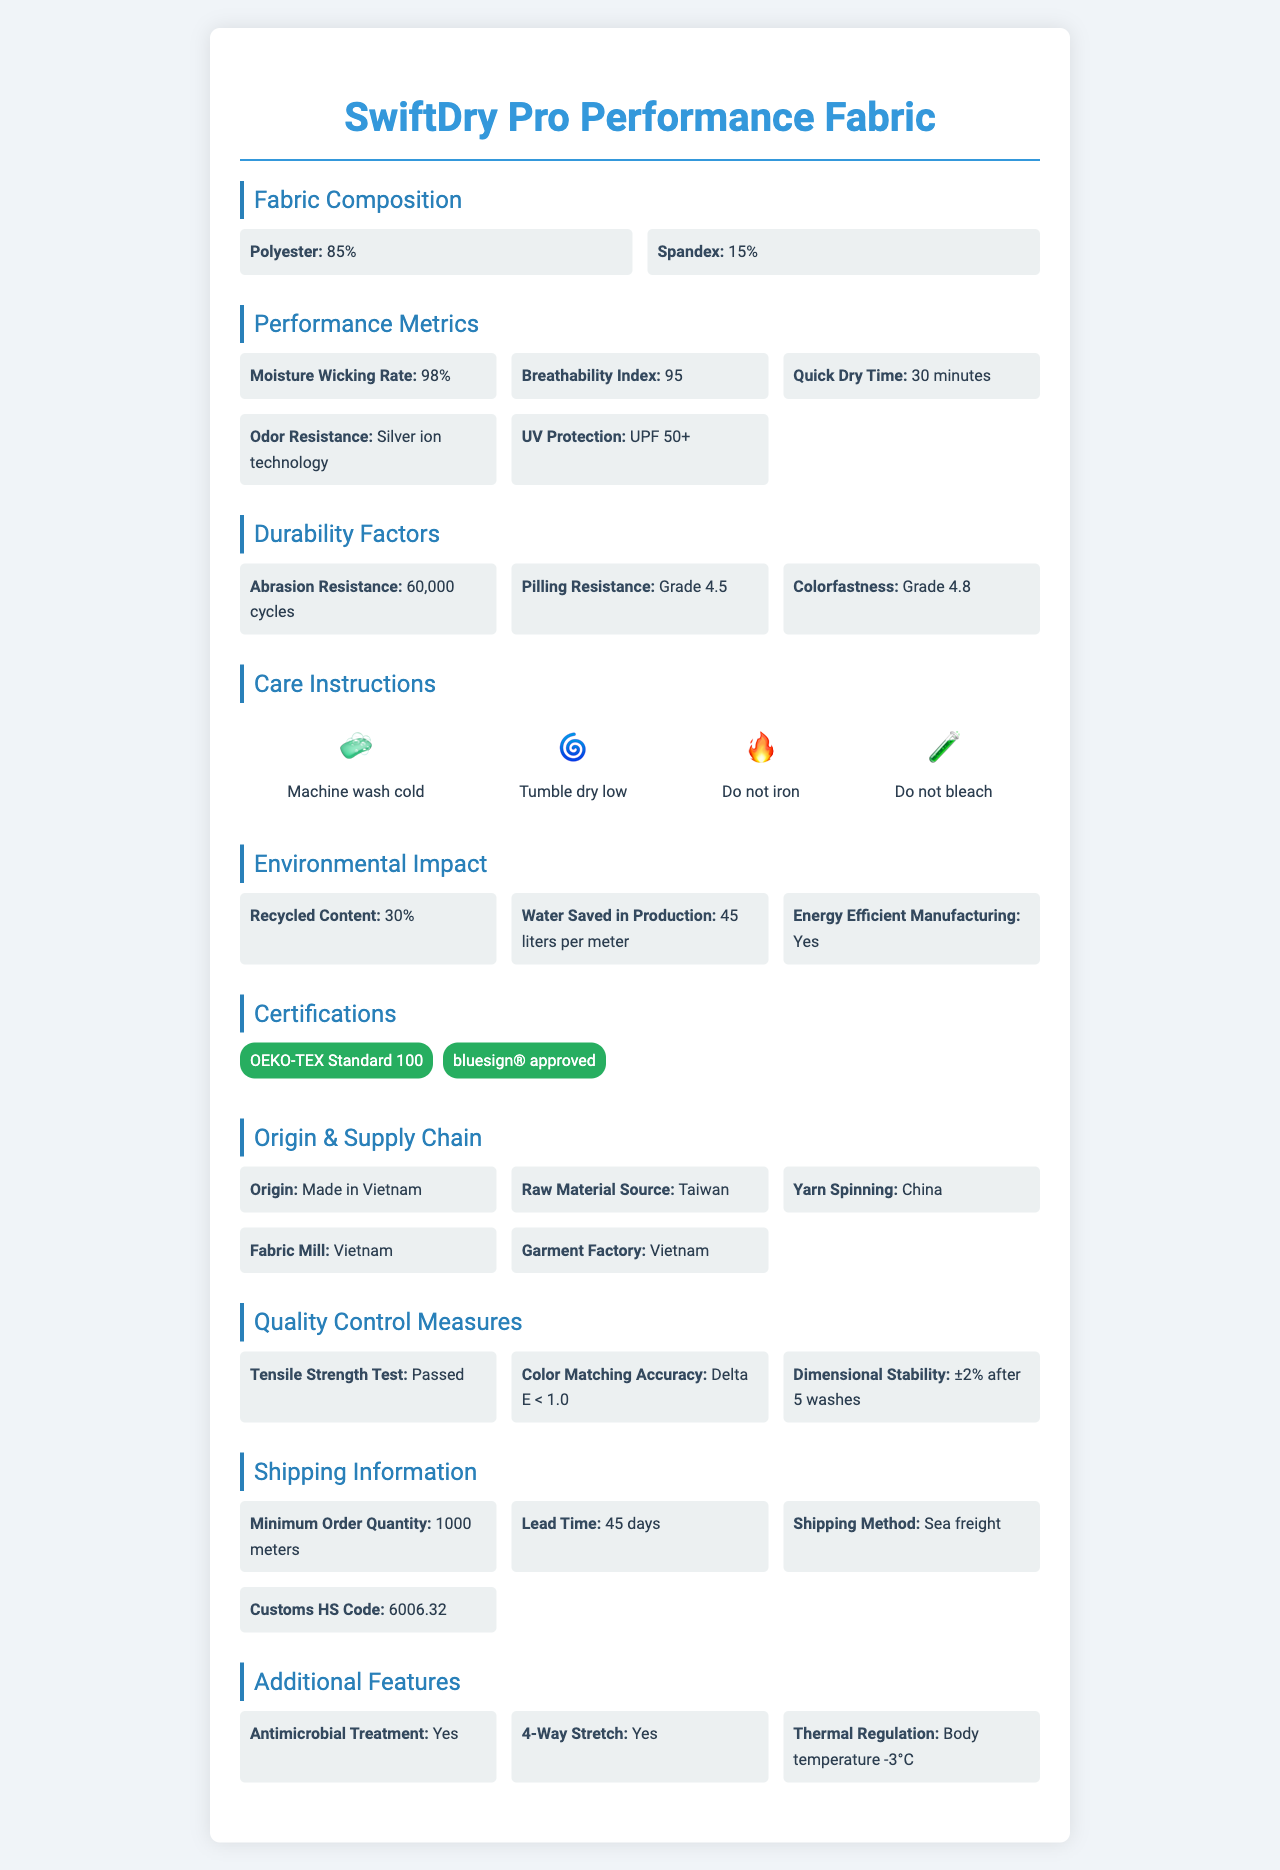what is the name of the fabric? The product name is mentioned at the top of the document, clearly stating "SwiftDry Pro Performance Fabric".
Answer: SwiftDry Pro Performance Fabric what percentage of the fabric composition is polyester? In the 'Fabric Composition' section, it states that the polyester content is 85%.
Answer: 85% how much water is saved in production per meter? In the 'Environmental Impact' section, it is noted that 45 liters per meter are saved in production.
Answer: 45 liters per meter what is the breathability index of this fabric? The 'Performance Metrics' section lists a breathability index of 95.
Answer: 95 what is the minimum order quantity for shipping? The 'Shipping Information' section specifies the minimum order quantity as 1000 meters.
Answer: 1000 meters In which country is the garment factory located? The 'Supply Chain Transparency' section mentions that the garment factory is in Vietnam.
Answer: Vietnam What is used for odor resistance in the fabric? The 'Performance Metrics' section states that silver ion technology is used for odor resistance.
Answer: Silver ion technology How should the fabric be washed? The 'Care Instructions' section advises to machine wash cold.
Answer: Machine wash cold which of the following is a performance metric of the fabric? A. Abrasion resistance B. Tensile strength test C. UV protection D. Washing UV protection is mentioned under 'Performance Metrics', while abrasion resistance and tensile strength test are listed under different sections.
Answer: C. UV protection What is the UV protection rating of the fabric? A. UPF 30 B. UPF 40 C. UPF 50 D. UPF 50+ The 'Performance Metrics' section specifically mentions "UPF 50+" for UV protection.
Answer: D. UPF 50+ Is the fabric antimicrobial treated? Under 'Additional Features', it mentions that the fabric has antimicrobial treatment.
Answer: Yes Does the fabric contain more than 20% spandex? The 'Fabric Composition' section states that the fabric contains 15% spandex.
Answer: No Summarize the main features of the SwiftDry Pro Performance Fabric. This summary captures the key elements related to fabric composition, performance metrics, additional features, environmental impacts, certifications, and supply chain details.
Answer: The SwiftDry Pro Performance Fabric is a high-performance athletic wear textile with an 85% polyester and 15% spandex composition. It offers superior moisture-wicking capabilities (98%), a high breathability index (95), quick dry time (30 minutes), and UPF 50+ UV protection. It also has added benefits of odor resistance with silver ion technology and antimicrobial treatment. The fabric is durable with high abrasion and pilling resistance and maintains its color well. Environmental benefits include 30% recycled content and significant water savings in production. The fabric is certified under OEKO-TEX Standard 100 and bluesign® approved. Manufacturing spans multiple countries with final assembly in Vietnam. What is the price per meter of the fabric? The document does not provide any information regarding the price per meter of the fabric.
Answer: Not enough information 